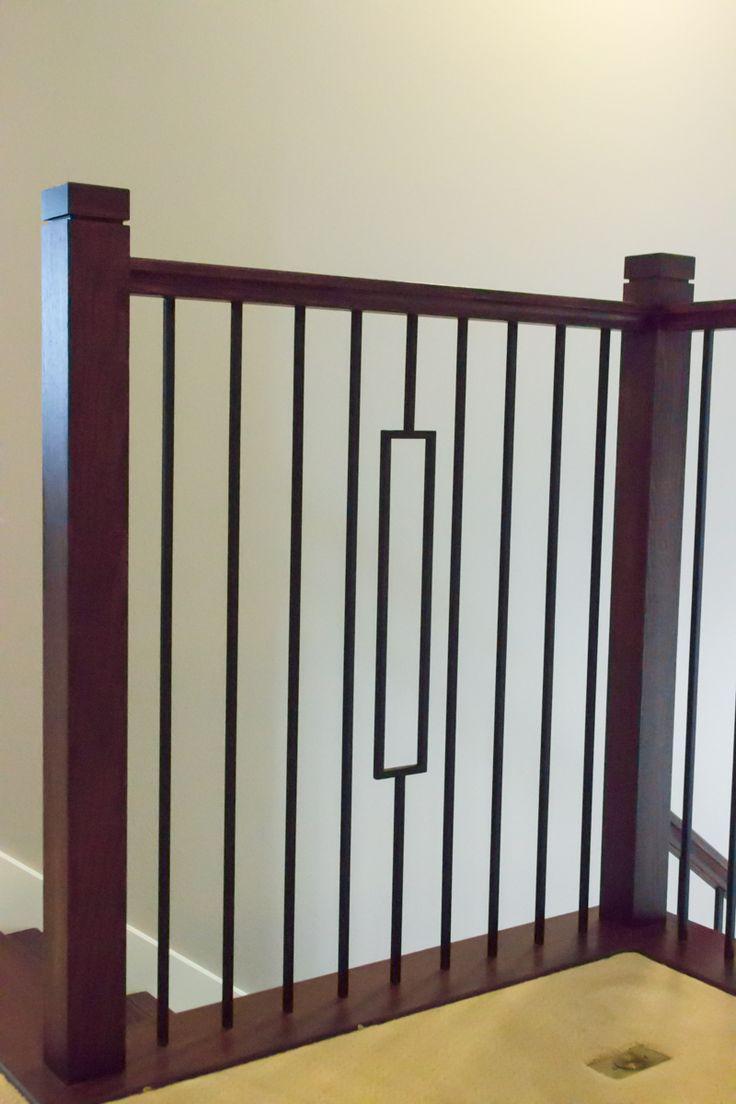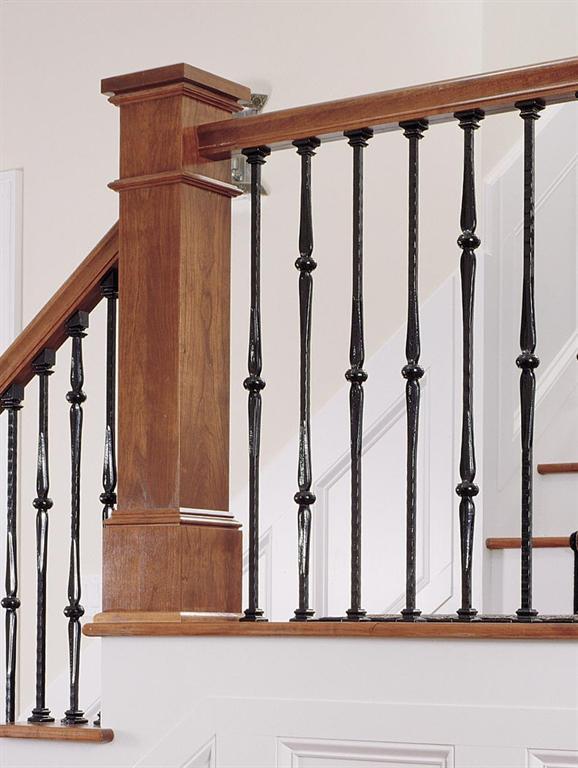The first image is the image on the left, the second image is the image on the right. For the images shown, is this caption "The left image shows the inside of a corner of a railing." true? Answer yes or no. Yes. 